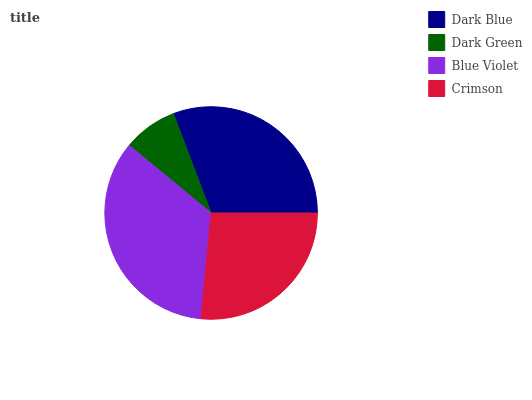Is Dark Green the minimum?
Answer yes or no. Yes. Is Blue Violet the maximum?
Answer yes or no. Yes. Is Blue Violet the minimum?
Answer yes or no. No. Is Dark Green the maximum?
Answer yes or no. No. Is Blue Violet greater than Dark Green?
Answer yes or no. Yes. Is Dark Green less than Blue Violet?
Answer yes or no. Yes. Is Dark Green greater than Blue Violet?
Answer yes or no. No. Is Blue Violet less than Dark Green?
Answer yes or no. No. Is Dark Blue the high median?
Answer yes or no. Yes. Is Crimson the low median?
Answer yes or no. Yes. Is Crimson the high median?
Answer yes or no. No. Is Dark Blue the low median?
Answer yes or no. No. 